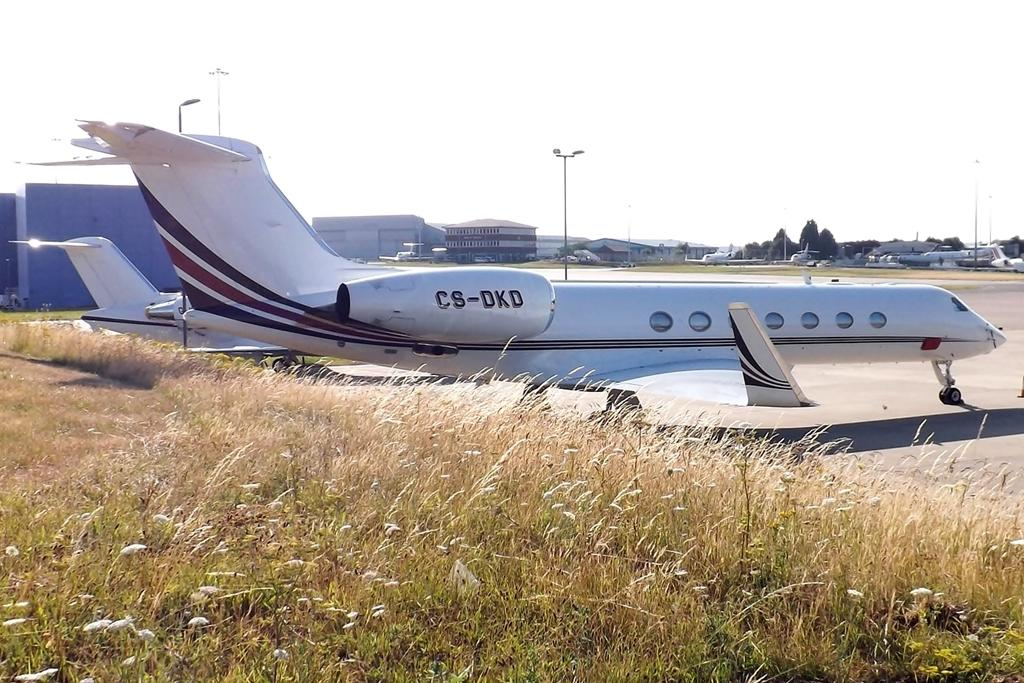Provide a one-sentence caption for the provided image. Cs-dkd wrote on a white and black airplane. 